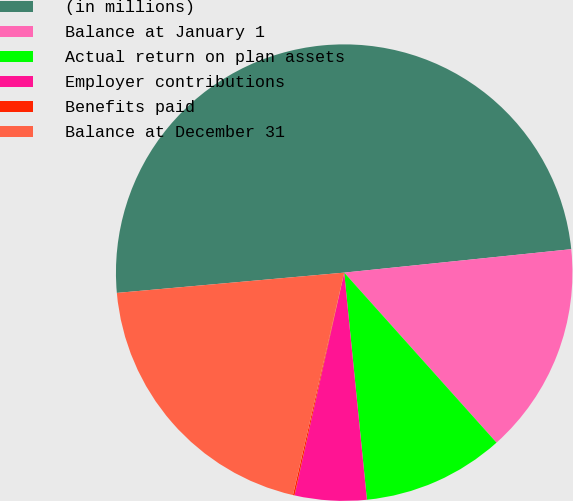Convert chart to OTSL. <chart><loc_0><loc_0><loc_500><loc_500><pie_chart><fcel>(in millions)<fcel>Balance at January 1<fcel>Actual return on plan assets<fcel>Employer contributions<fcel>Benefits paid<fcel>Balance at December 31<nl><fcel>49.78%<fcel>15.01%<fcel>10.04%<fcel>5.08%<fcel>0.11%<fcel>19.98%<nl></chart> 